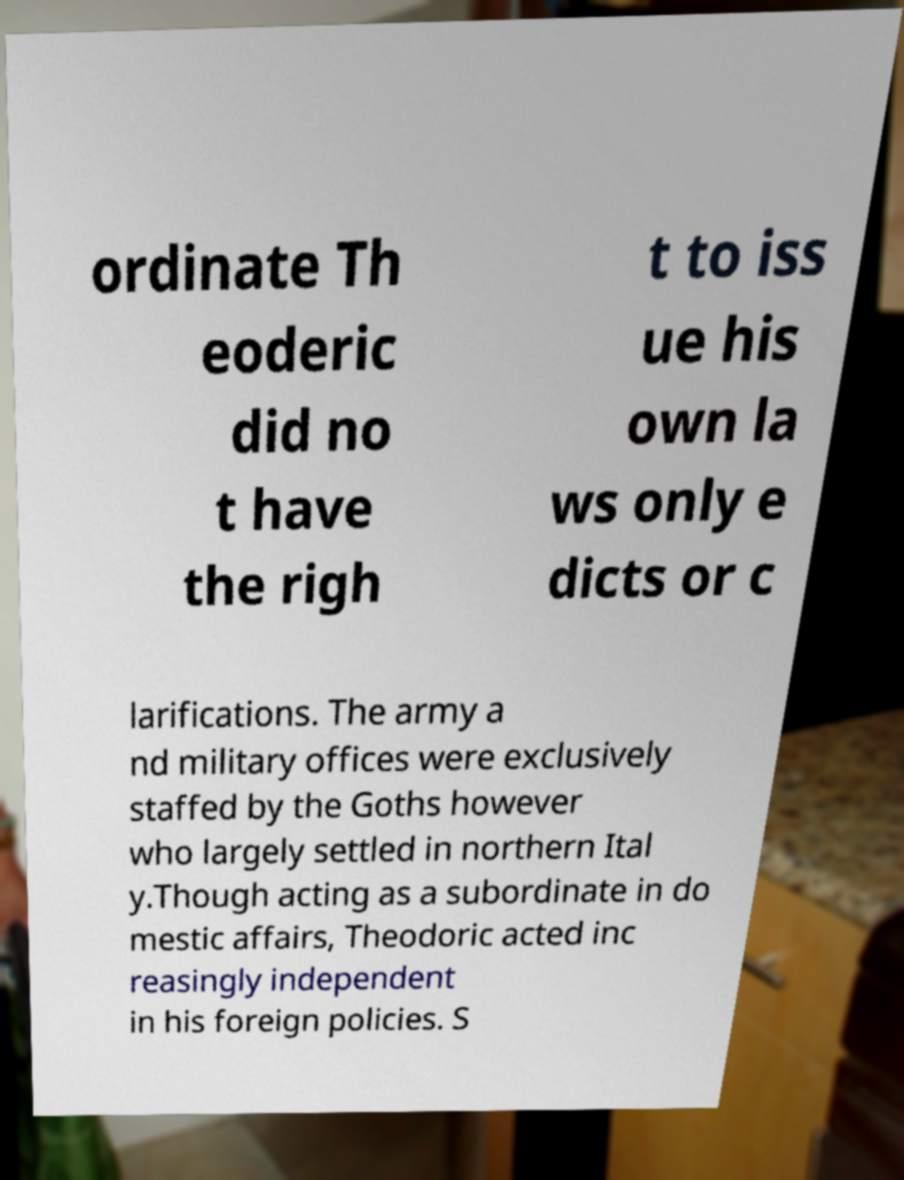For documentation purposes, I need the text within this image transcribed. Could you provide that? ordinate Th eoderic did no t have the righ t to iss ue his own la ws only e dicts or c larifications. The army a nd military offices were exclusively staffed by the Goths however who largely settled in northern Ital y.Though acting as a subordinate in do mestic affairs, Theodoric acted inc reasingly independent in his foreign policies. S 